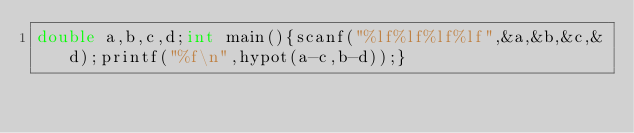Convert code to text. <code><loc_0><loc_0><loc_500><loc_500><_C_>double a,b,c,d;int main(){scanf("%lf%lf%lf%lf",&a,&b,&c,&d);printf("%f\n",hypot(a-c,b-d));}</code> 